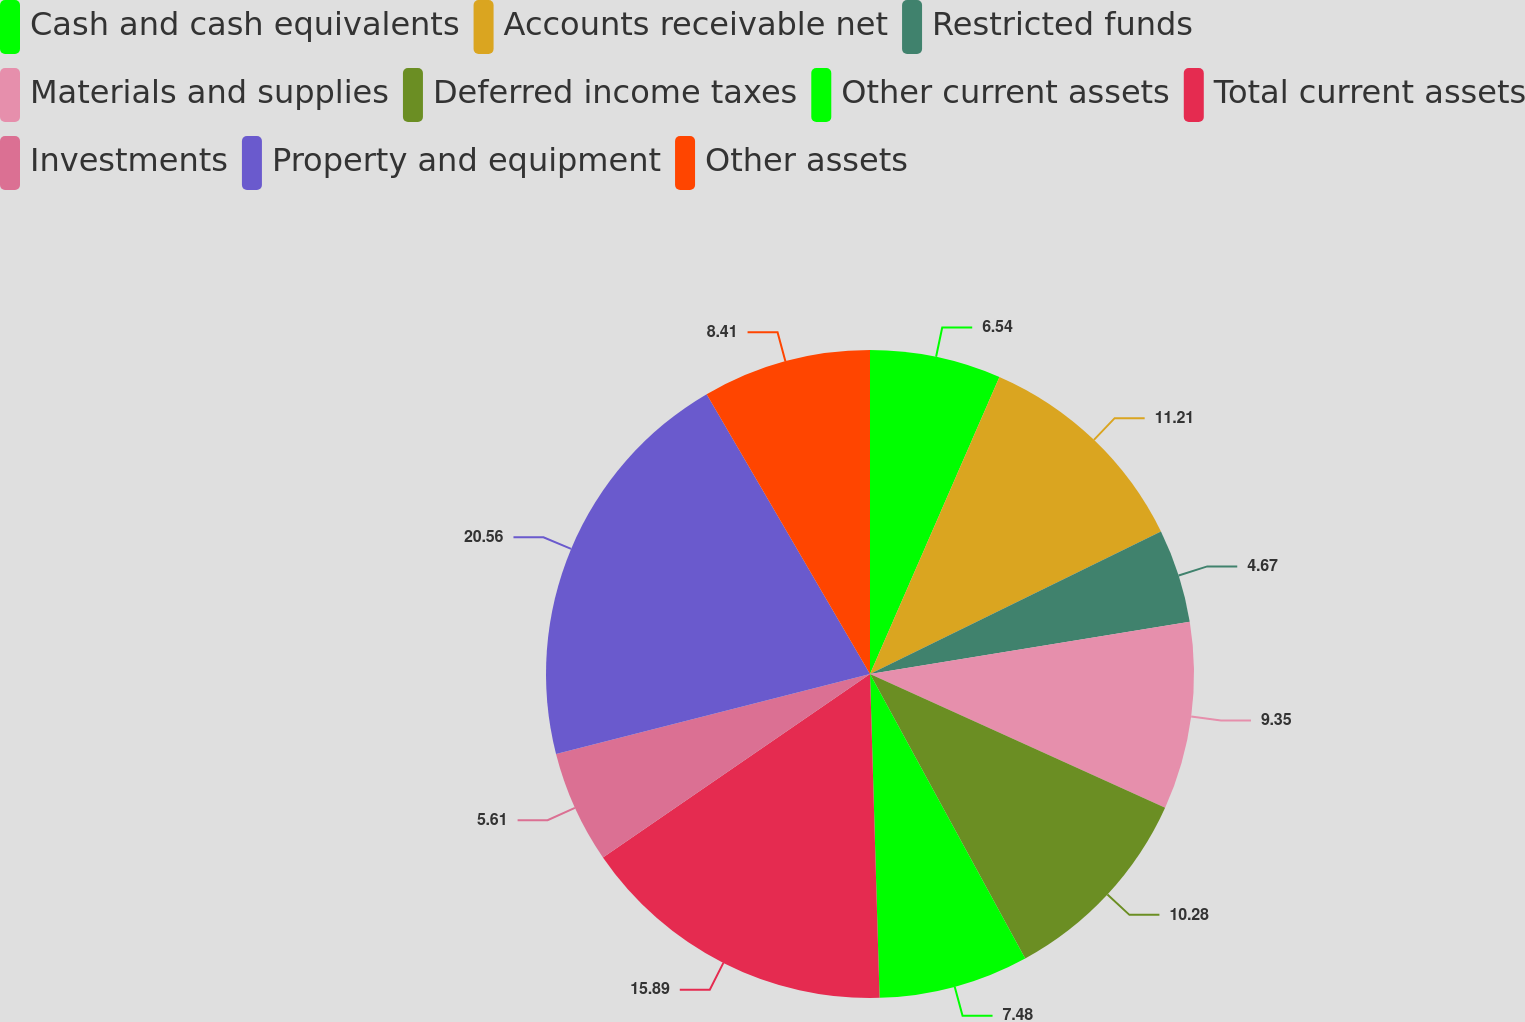Convert chart to OTSL. <chart><loc_0><loc_0><loc_500><loc_500><pie_chart><fcel>Cash and cash equivalents<fcel>Accounts receivable net<fcel>Restricted funds<fcel>Materials and supplies<fcel>Deferred income taxes<fcel>Other current assets<fcel>Total current assets<fcel>Investments<fcel>Property and equipment<fcel>Other assets<nl><fcel>6.54%<fcel>11.21%<fcel>4.67%<fcel>9.35%<fcel>10.28%<fcel>7.48%<fcel>15.89%<fcel>5.61%<fcel>20.56%<fcel>8.41%<nl></chart> 